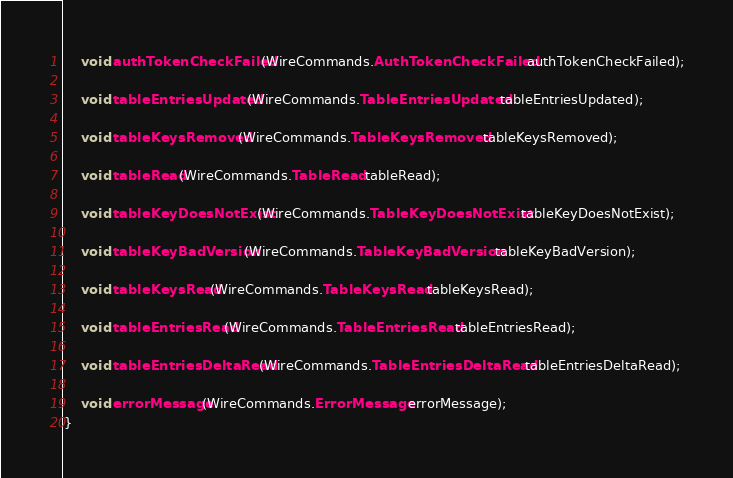<code> <loc_0><loc_0><loc_500><loc_500><_Java_>
    void authTokenCheckFailed(WireCommands.AuthTokenCheckFailed authTokenCheckFailed);

    void tableEntriesUpdated(WireCommands.TableEntriesUpdated tableEntriesUpdated);

    void tableKeysRemoved(WireCommands.TableKeysRemoved tableKeysRemoved);

    void tableRead(WireCommands.TableRead tableRead);

    void tableKeyDoesNotExist(WireCommands.TableKeyDoesNotExist tableKeyDoesNotExist);

    void tableKeyBadVersion(WireCommands.TableKeyBadVersion tableKeyBadVersion);

    void tableKeysRead(WireCommands.TableKeysRead tableKeysRead);

    void tableEntriesRead(WireCommands.TableEntriesRead tableEntriesRead);

    void tableEntriesDeltaRead(WireCommands.TableEntriesDeltaRead tableEntriesDeltaRead);

    void errorMessage(WireCommands.ErrorMessage errorMessage);
}
</code> 